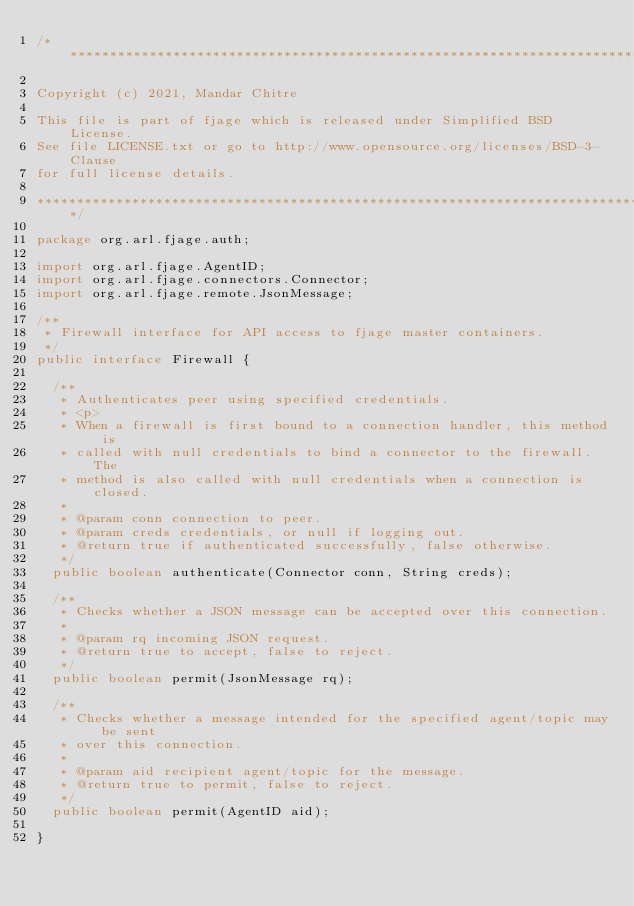Convert code to text. <code><loc_0><loc_0><loc_500><loc_500><_Java_>/******************************************************************************

Copyright (c) 2021, Mandar Chitre

This file is part of fjage which is released under Simplified BSD License.
See file LICENSE.txt or go to http://www.opensource.org/licenses/BSD-3-Clause
for full license details.

******************************************************************************/

package org.arl.fjage.auth;

import org.arl.fjage.AgentID;
import org.arl.fjage.connectors.Connector;
import org.arl.fjage.remote.JsonMessage;

/**
 * Firewall interface for API access to fjage master containers.
 */
public interface Firewall {

  /**
   * Authenticates peer using specified credentials.
   * <p>
   * When a firewall is first bound to a connection handler, this method is
   * called with null credentials to bind a connector to the firewall. The
   * method is also called with null credentials when a connection is closed.
   *
   * @param conn connection to peer.
   * @param creds credentials, or null if logging out.
   * @return true if authenticated successfully, false otherwise.
   */
  public boolean authenticate(Connector conn, String creds);

  /**
   * Checks whether a JSON message can be accepted over this connection.
   *
   * @param rq incoming JSON request.
   * @return true to accept, false to reject.
   */
  public boolean permit(JsonMessage rq);

  /**
   * Checks whether a message intended for the specified agent/topic may be sent
   * over this connection.
   *
   * @param aid recipient agent/topic for the message.
   * @return true to permit, false to reject.
   */
  public boolean permit(AgentID aid);

}
</code> 